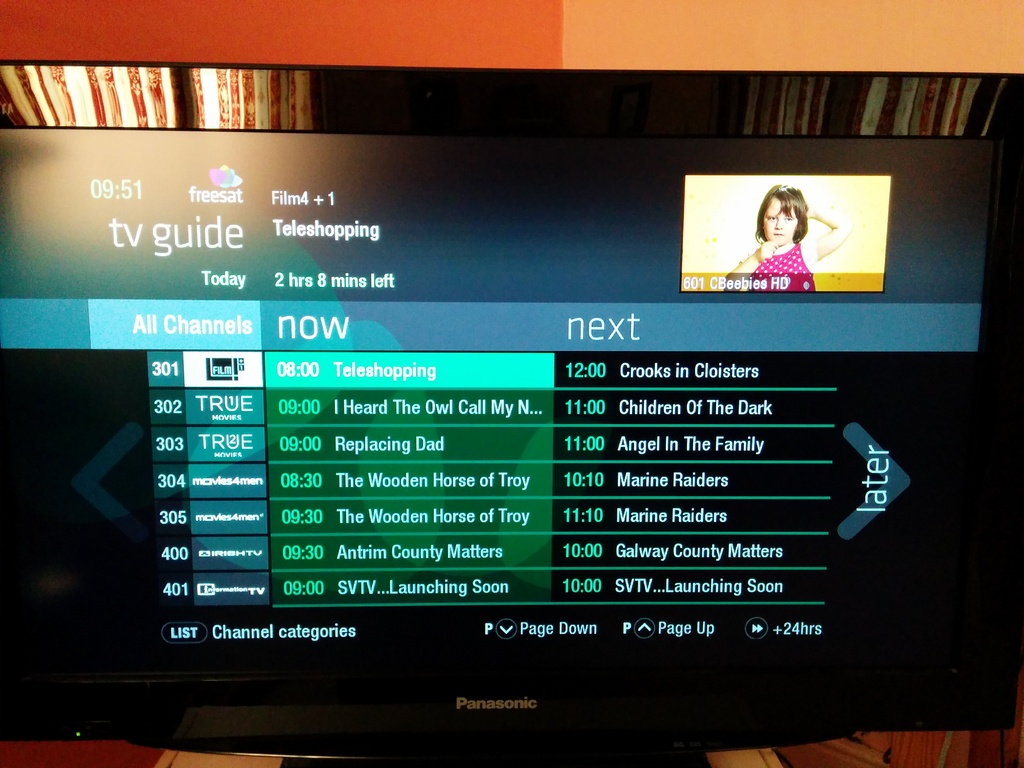Provide a one-sentence caption for the provided image. The image displays a TV guide on a screen, showing a schedule of various programs across multiple channels including Film4 +1 and True Movies, with the current selection highlighting a movie 'I Heard The Owl Call My Name' on True Movies at 09:00. 